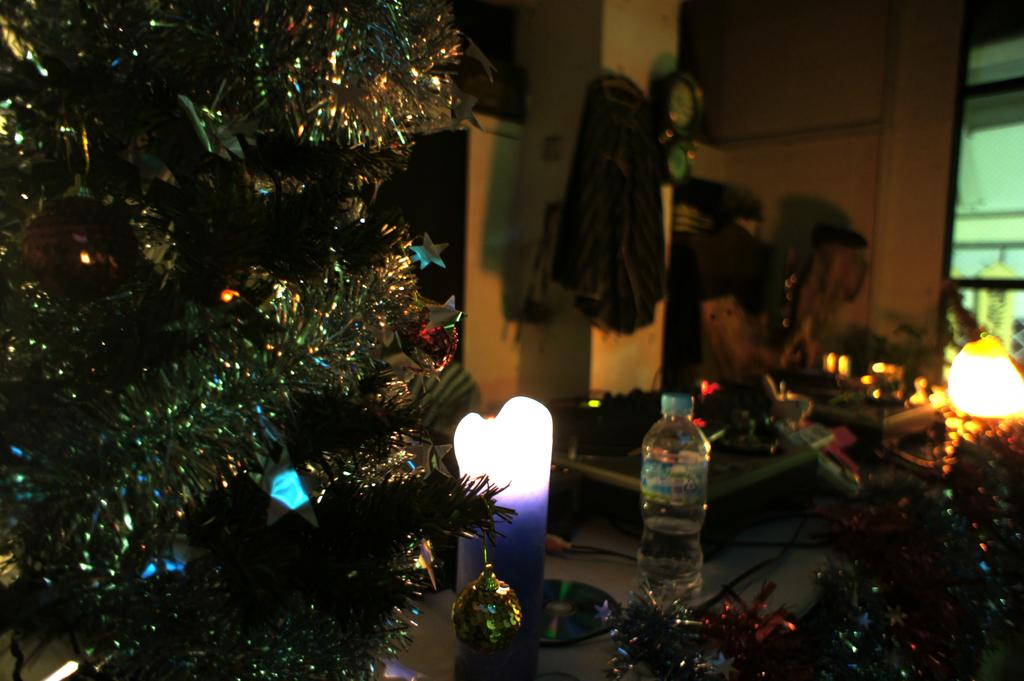What is one object that can be seen in the image? There is a bottle in the image. What else can be seen in the image besides the bottle? There are lights and other things on the table in the image. Are there any decorative elements visible in the image? Yes, there are decorative things beside the table in the image. Can you describe an object visible in the background of the image? There is a glass visible in the background of the image. What type of heart can be seen beating in the image? There is no heart visible in the image. 